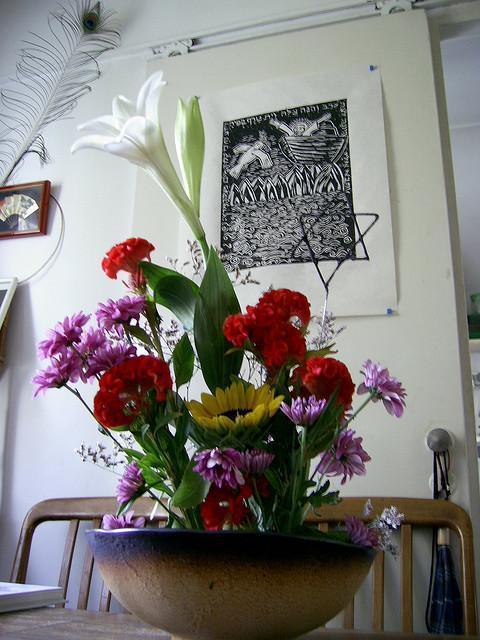How many chairs can you see?
Give a very brief answer. 2. How many bowls can you see?
Give a very brief answer. 1. 